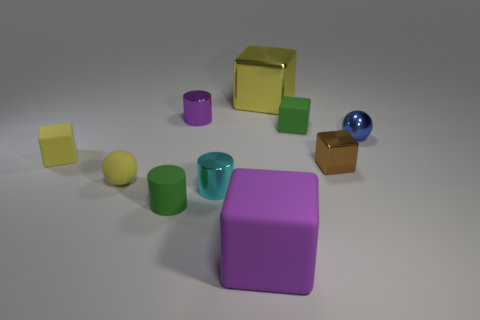There is a purple thing in front of the purple cylinder; is its size the same as the small green cylinder? No, the purple object in question is larger than the small green cylinder when comparing their sizes. 